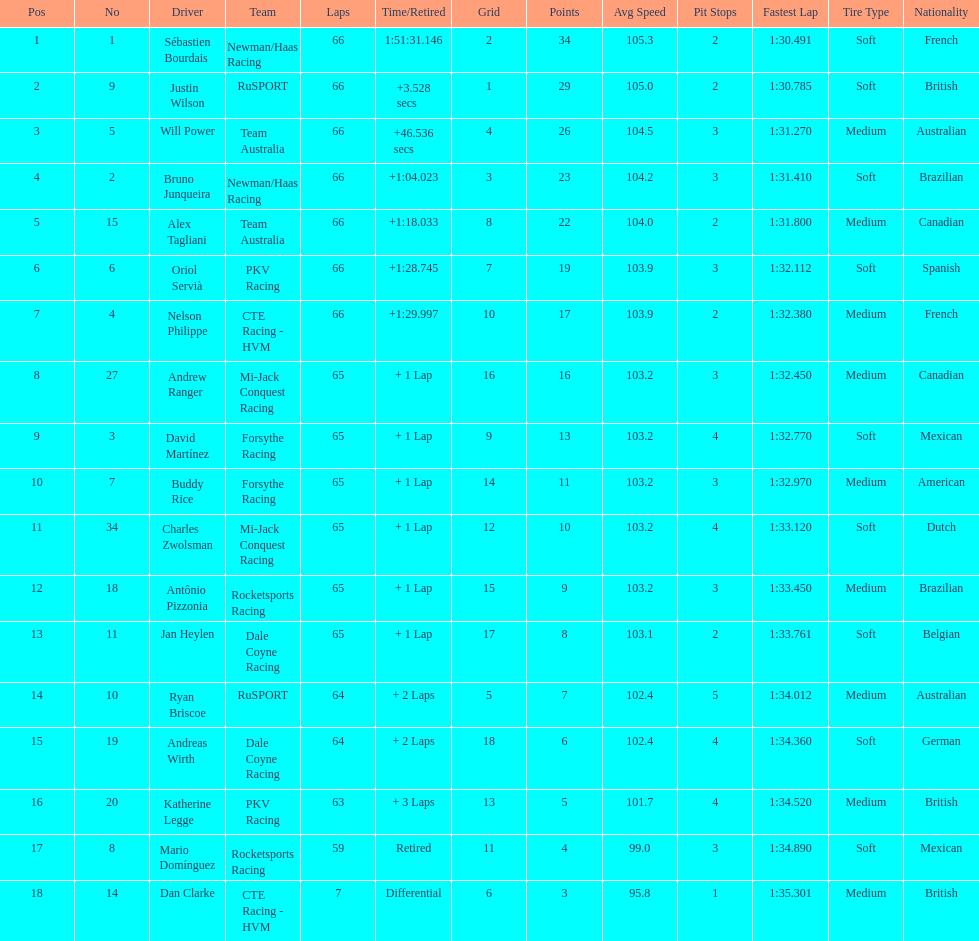Which country had more drivers representing them, the us or germany? Tie. 